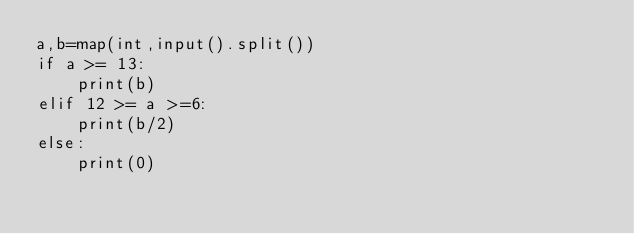<code> <loc_0><loc_0><loc_500><loc_500><_Python_>a,b=map(int,input().split())
if a >= 13:
    print(b)
elif 12 >= a >=6:
    print(b/2)
else:
    print(0)</code> 